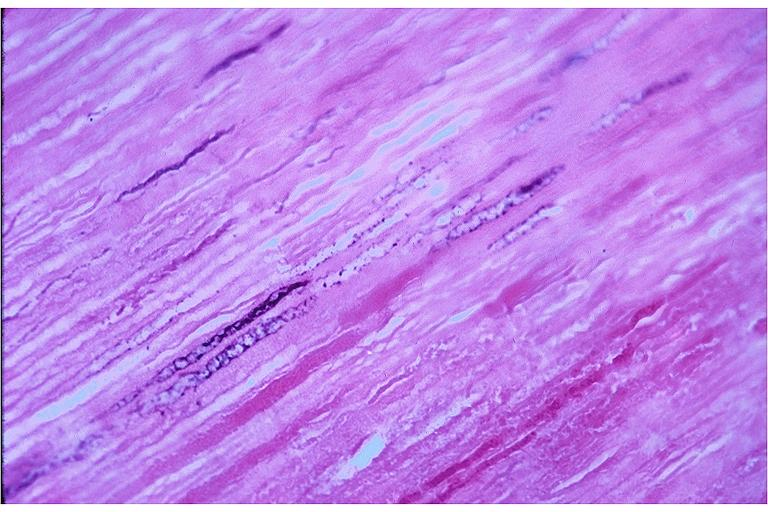does malformed base show caries?
Answer the question using a single word or phrase. No 